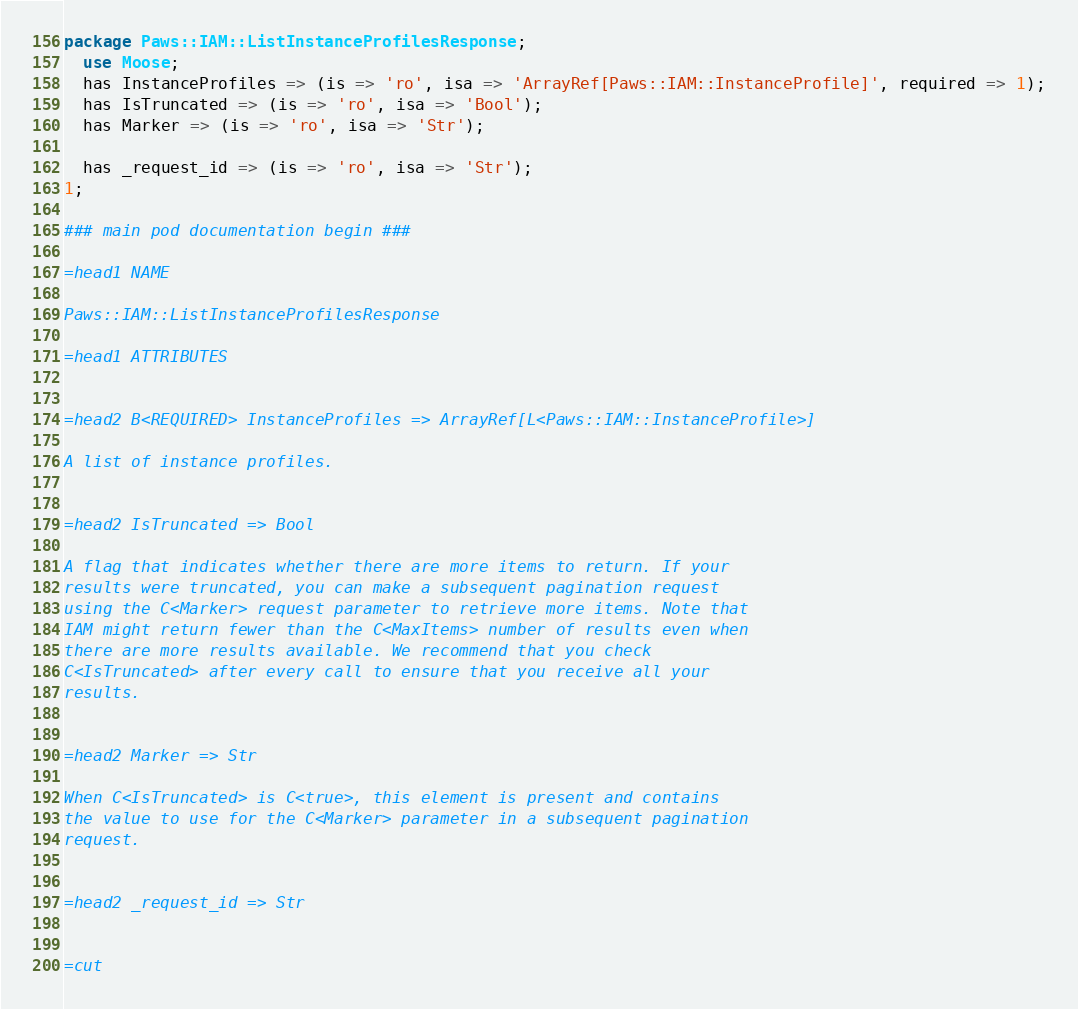<code> <loc_0><loc_0><loc_500><loc_500><_Perl_>
package Paws::IAM::ListInstanceProfilesResponse;
  use Moose;
  has InstanceProfiles => (is => 'ro', isa => 'ArrayRef[Paws::IAM::InstanceProfile]', required => 1);
  has IsTruncated => (is => 'ro', isa => 'Bool');
  has Marker => (is => 'ro', isa => 'Str');

  has _request_id => (is => 'ro', isa => 'Str');
1;

### main pod documentation begin ###

=head1 NAME

Paws::IAM::ListInstanceProfilesResponse

=head1 ATTRIBUTES


=head2 B<REQUIRED> InstanceProfiles => ArrayRef[L<Paws::IAM::InstanceProfile>]

A list of instance profiles.


=head2 IsTruncated => Bool

A flag that indicates whether there are more items to return. If your
results were truncated, you can make a subsequent pagination request
using the C<Marker> request parameter to retrieve more items. Note that
IAM might return fewer than the C<MaxItems> number of results even when
there are more results available. We recommend that you check
C<IsTruncated> after every call to ensure that you receive all your
results.


=head2 Marker => Str

When C<IsTruncated> is C<true>, this element is present and contains
the value to use for the C<Marker> parameter in a subsequent pagination
request.


=head2 _request_id => Str


=cut

</code> 